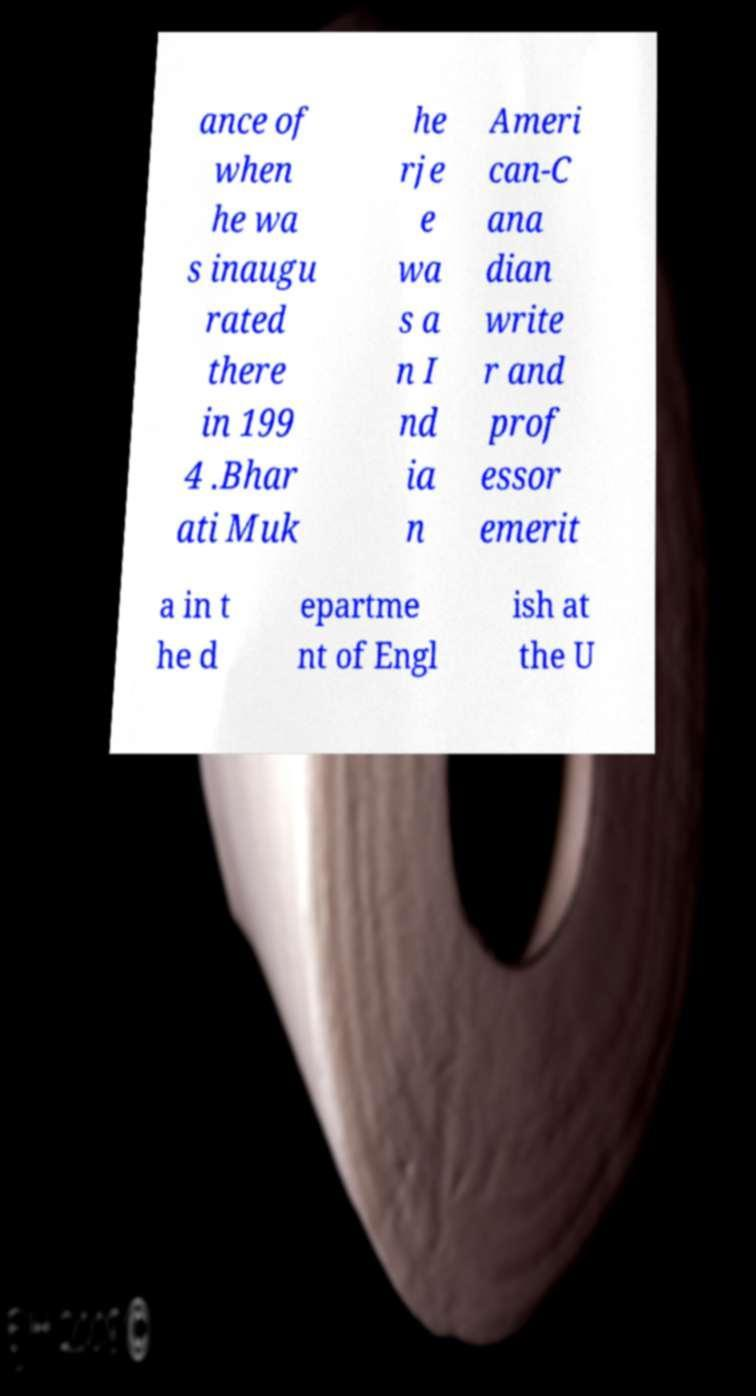Please identify and transcribe the text found in this image. ance of when he wa s inaugu rated there in 199 4 .Bhar ati Muk he rje e wa s a n I nd ia n Ameri can-C ana dian write r and prof essor emerit a in t he d epartme nt of Engl ish at the U 